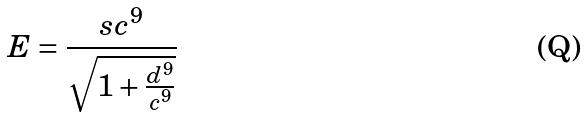<formula> <loc_0><loc_0><loc_500><loc_500>E = \frac { s c ^ { 9 } } { \sqrt { 1 + \frac { d ^ { 9 } } { c ^ { 9 } } } }</formula> 